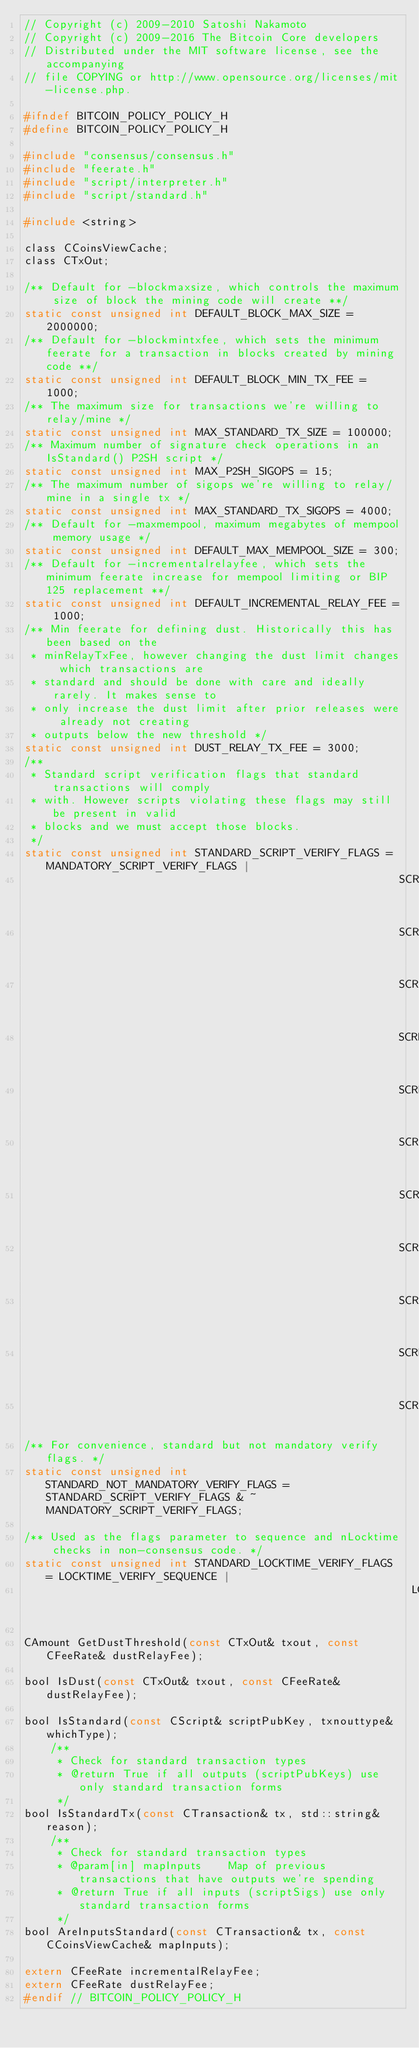Convert code to text. <code><loc_0><loc_0><loc_500><loc_500><_C_>// Copyright (c) 2009-2010 Satoshi Nakamoto
// Copyright (c) 2009-2016 The Bitcoin Core developers
// Distributed under the MIT software license, see the accompanying
// file COPYING or http://www.opensource.org/licenses/mit-license.php.

#ifndef BITCOIN_POLICY_POLICY_H
#define BITCOIN_POLICY_POLICY_H

#include "consensus/consensus.h"
#include "feerate.h"
#include "script/interpreter.h"
#include "script/standard.h"

#include <string>

class CCoinsViewCache;
class CTxOut;

/** Default for -blockmaxsize, which controls the maximum size of block the mining code will create **/
static const unsigned int DEFAULT_BLOCK_MAX_SIZE = 2000000;
/** Default for -blockmintxfee, which sets the minimum feerate for a transaction in blocks created by mining code **/
static const unsigned int DEFAULT_BLOCK_MIN_TX_FEE = 1000;
/** The maximum size for transactions we're willing to relay/mine */
static const unsigned int MAX_STANDARD_TX_SIZE = 100000;
/** Maximum number of signature check operations in an IsStandard() P2SH script */
static const unsigned int MAX_P2SH_SIGOPS = 15;
/** The maximum number of sigops we're willing to relay/mine in a single tx */
static const unsigned int MAX_STANDARD_TX_SIGOPS = 4000;
/** Default for -maxmempool, maximum megabytes of mempool memory usage */
static const unsigned int DEFAULT_MAX_MEMPOOL_SIZE = 300;
/** Default for -incrementalrelayfee, which sets the minimum feerate increase for mempool limiting or BIP 125 replacement **/
static const unsigned int DEFAULT_INCREMENTAL_RELAY_FEE = 1000;
/** Min feerate for defining dust. Historically this has been based on the
 * minRelayTxFee, however changing the dust limit changes which transactions are
 * standard and should be done with care and ideally rarely. It makes sense to
 * only increase the dust limit after prior releases were already not creating
 * outputs below the new threshold */
static const unsigned int DUST_RELAY_TX_FEE = 3000;
/**
 * Standard script verification flags that standard transactions will comply
 * with. However scripts violating these flags may still be present in valid
 * blocks and we must accept those blocks.
 */
static const unsigned int STANDARD_SCRIPT_VERIFY_FLAGS = MANDATORY_SCRIPT_VERIFY_FLAGS |
                                                         SCRIPT_VERIFY_DERSIG |
                                                         SCRIPT_VERIFY_STRICTENC |
                                                         SCRIPT_VERIFY_MINIMALDATA |
                                                         SCRIPT_VERIFY_NULLDUMMY |
                                                         SCRIPT_VERIFY_DISCOURAGE_UPGRADABLE_NOPS |
                                                         SCRIPT_VERIFY_CLEANSTACK |
                                                         SCRIPT_VERIFY_NULLFAIL |
                                                         SCRIPT_VERIFY_CHECKLOCKTIMEVERIFY |
                                                         SCRIPT_VERIFY_CHECKSEQUENCEVERIFY |
                                                         SCRIPT_VERIFY_LOW_S |
                                                         SCRIPT_ENABLE_DIP0020_OPCODES;
/** For convenience, standard but not mandatory verify flags. */
static const unsigned int STANDARD_NOT_MANDATORY_VERIFY_FLAGS = STANDARD_SCRIPT_VERIFY_FLAGS & ~MANDATORY_SCRIPT_VERIFY_FLAGS;

/** Used as the flags parameter to sequence and nLocktime checks in non-consensus code. */
static const unsigned int STANDARD_LOCKTIME_VERIFY_FLAGS = LOCKTIME_VERIFY_SEQUENCE |
                                                           LOCKTIME_MEDIAN_TIME_PAST;

CAmount GetDustThreshold(const CTxOut& txout, const CFeeRate& dustRelayFee);

bool IsDust(const CTxOut& txout, const CFeeRate& dustRelayFee);

bool IsStandard(const CScript& scriptPubKey, txnouttype& whichType);
    /**
     * Check for standard transaction types
     * @return True if all outputs (scriptPubKeys) use only standard transaction forms
     */
bool IsStandardTx(const CTransaction& tx, std::string& reason);
    /**
     * Check for standard transaction types
     * @param[in] mapInputs    Map of previous transactions that have outputs we're spending
     * @return True if all inputs (scriptSigs) use only standard transaction forms
     */
bool AreInputsStandard(const CTransaction& tx, const CCoinsViewCache& mapInputs);

extern CFeeRate incrementalRelayFee;
extern CFeeRate dustRelayFee;
#endif // BITCOIN_POLICY_POLICY_H
</code> 